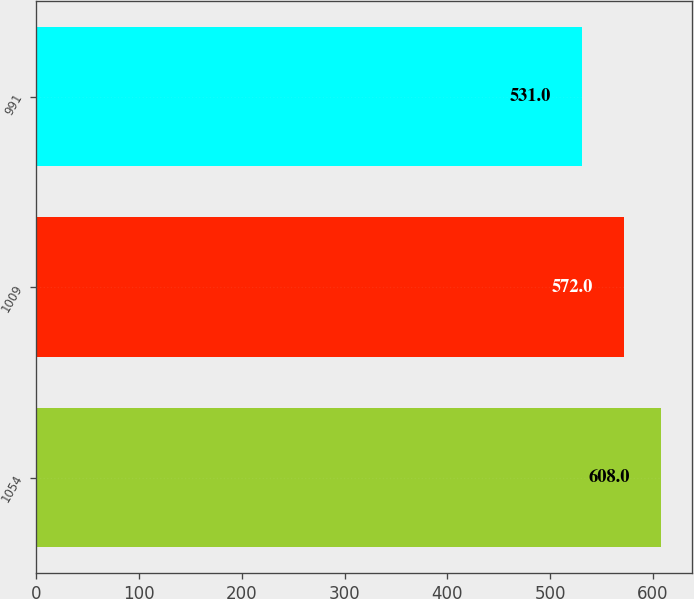Convert chart. <chart><loc_0><loc_0><loc_500><loc_500><bar_chart><fcel>1054<fcel>1009<fcel>991<nl><fcel>608<fcel>572<fcel>531<nl></chart> 